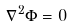Convert formula to latex. <formula><loc_0><loc_0><loc_500><loc_500>\, \nabla ^ { 2 } \Phi = 0</formula> 